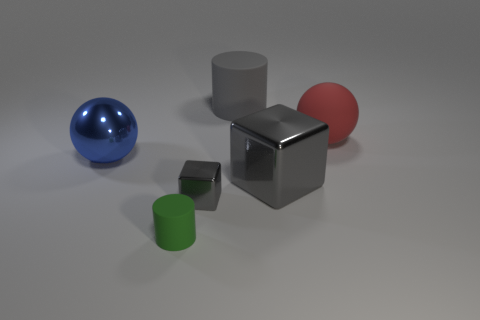Describe the lighting and shadows in the scene. The lighting in the scene appears to be diffused, likely from an overhead soft light source, creating soft shadows that gently stretch away from the objects. The positioning suggests a single light source casting consistent shadows, providing an even illumination across the entire scene. 